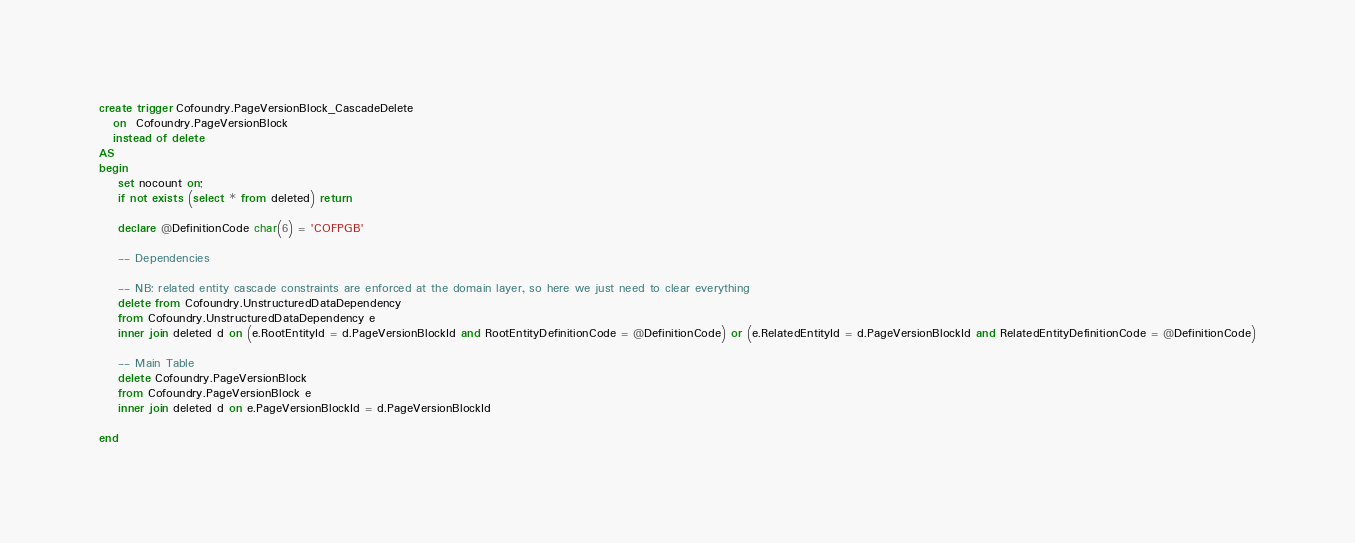Convert code to text. <code><loc_0><loc_0><loc_500><loc_500><_SQL_>create trigger Cofoundry.PageVersionBlock_CascadeDelete
   on  Cofoundry.PageVersionBlock
   instead of delete
AS 
begin
	set nocount on;
	if not exists (select * from deleted) return
	
	declare @DefinitionCode char(6) = 'COFPGB'

	-- Dependencies

	-- NB: related entity cascade constraints are enforced at the domain layer, so here we just need to clear everything
	delete from Cofoundry.UnstructuredDataDependency
	from Cofoundry.UnstructuredDataDependency e
	inner join deleted d on (e.RootEntityId = d.PageVersionBlockId and RootEntityDefinitionCode = @DefinitionCode) or (e.RelatedEntityId = d.PageVersionBlockId and RelatedEntityDefinitionCode = @DefinitionCode)
	
	-- Main Table
    delete Cofoundry.PageVersionBlock
	from Cofoundry.PageVersionBlock e
	inner join deleted d on e.PageVersionBlockId = d.PageVersionBlockId

end</code> 